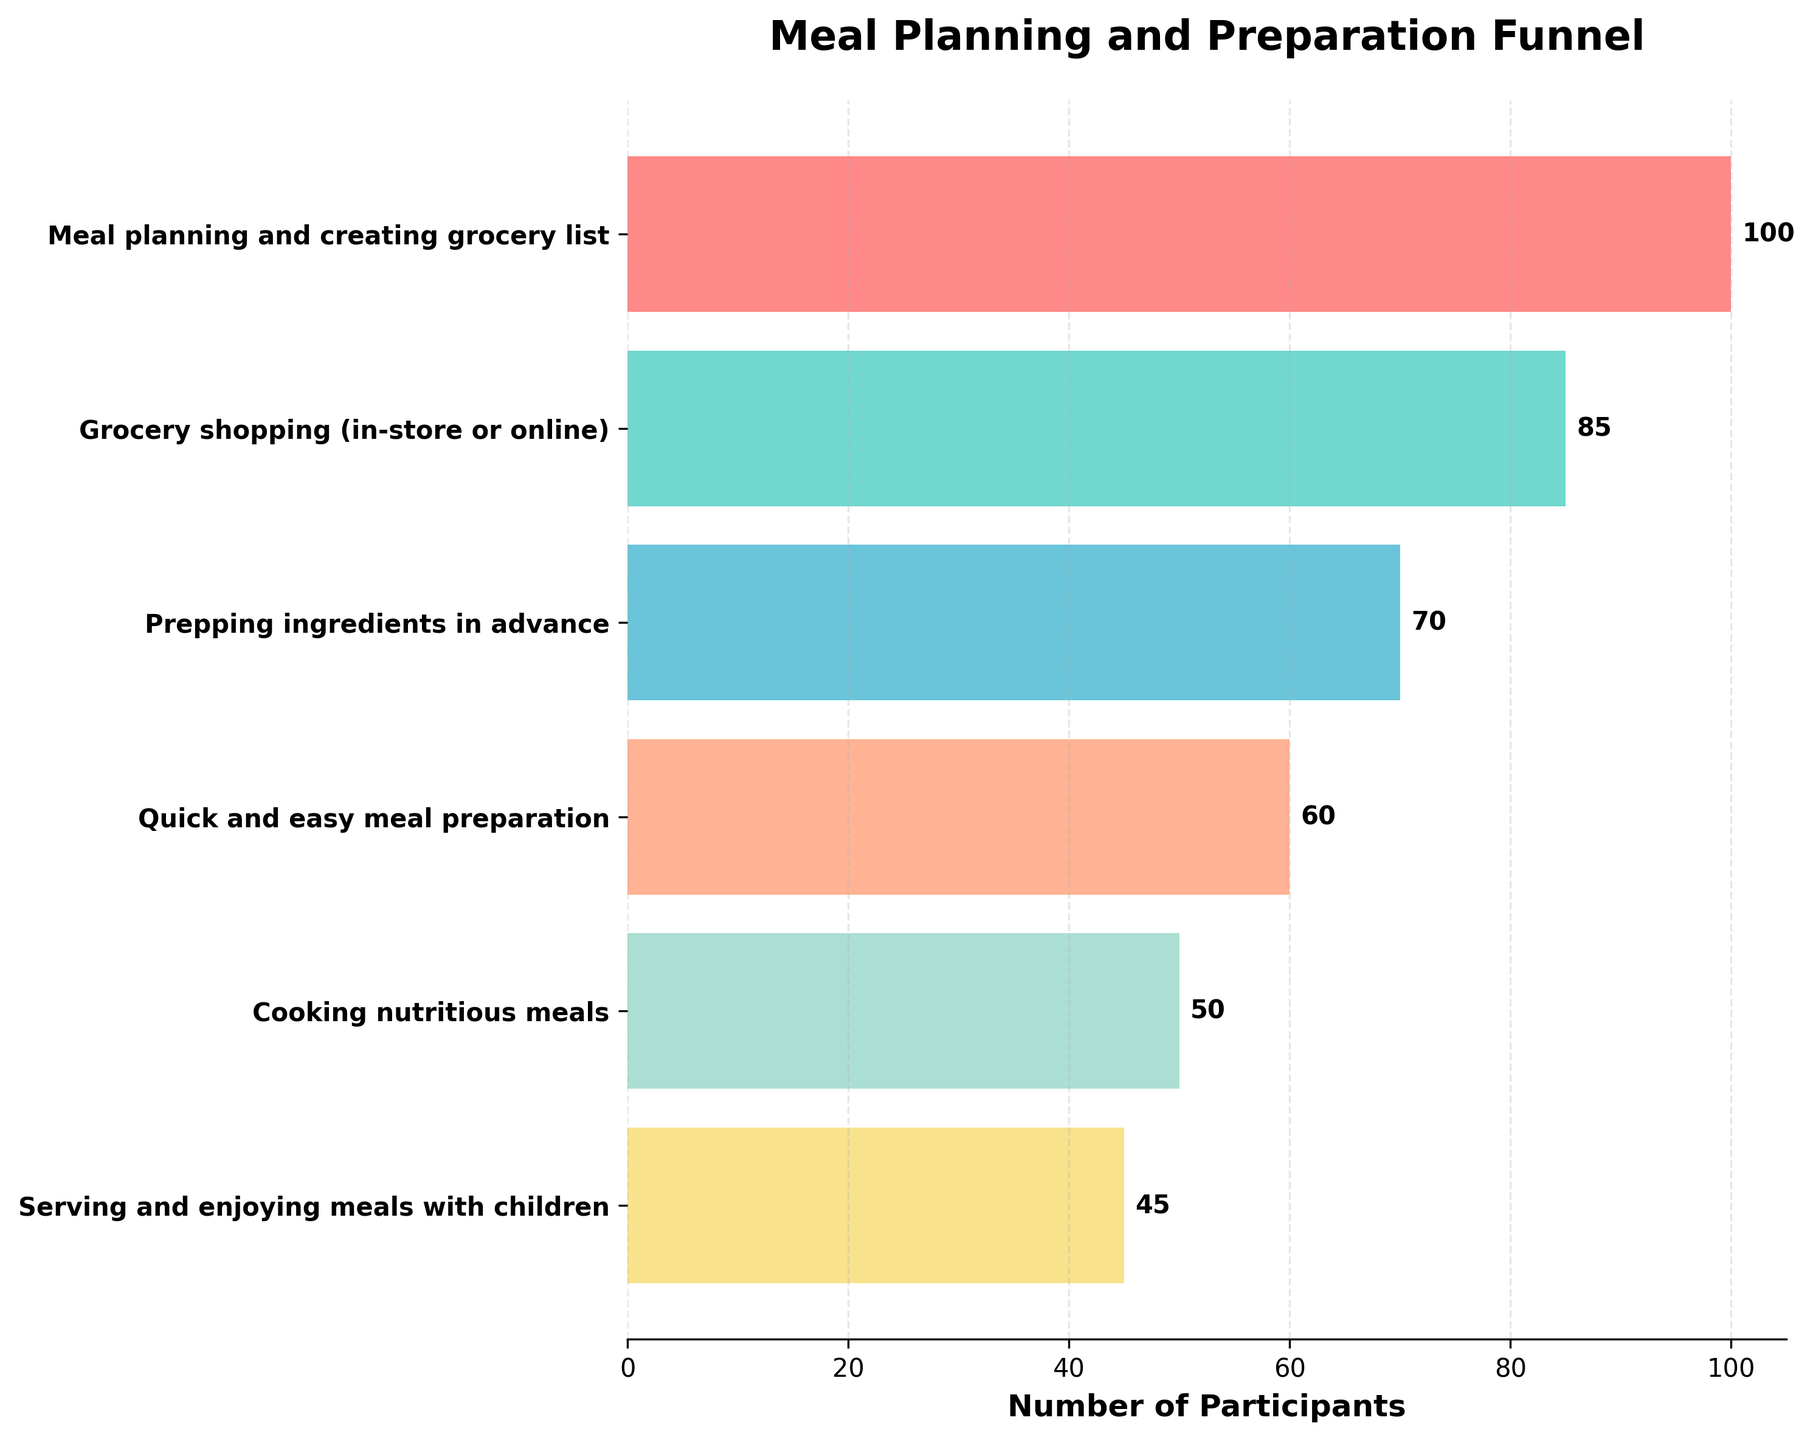What is the title of the funnel chart? Look at the top of the chart, where the title is usually located.
Answer: Meal Planning and Preparation Funnel How many steps are included in the meal planning and preparation process? Count the number of distinct steps listed on the y-axis.
Answer: 6 What is the color of the bar representing the step "Meal planning and creating grocery list"? Look at the color of the bar corresponding to "Meal planning and creating grocery list" on the y-axis.
Answer: Red Which step has the highest number of participants? Find the step with the longest bar on the x-axis.
Answer: Meal planning and creating grocery list By how many participants does "Grocery shopping (in-store or online)" differ from "Prepping ingredients in advance"? Subtract the number of participants in "Prepping ingredients in advance" from the number in "Grocery shopping (in-store or online)" (85 - 70).
Answer: 15 What is the number of participants at the final step "Serving and enjoying meals with children"? Look at the number at the end of the bar corresponding to the final step.
Answer: 45 Which step has the least number of participants? Find the step with the shortest bar on the x-axis.
Answer: Serving and enjoying meals with children What is the combined number of participants for "Prepping ingredients in advance" and "Cooking nutritious meals"? Add the number of participants in both steps together (70 + 50).
Answer: 120 How many participants drop off between "Cooking nutritious meals" and "Serving and enjoying meals with children"? Subtract the number of participants in "Serving and enjoying meals with children" from that in "Cooking nutritious meals" (50 - 45).
Answer: 5 If we want to compare the drop-off from the first step to the last step, what is the difference in participants? Subtract the number of participants in the last step from the first step (100 - 45).
Answer: 55 